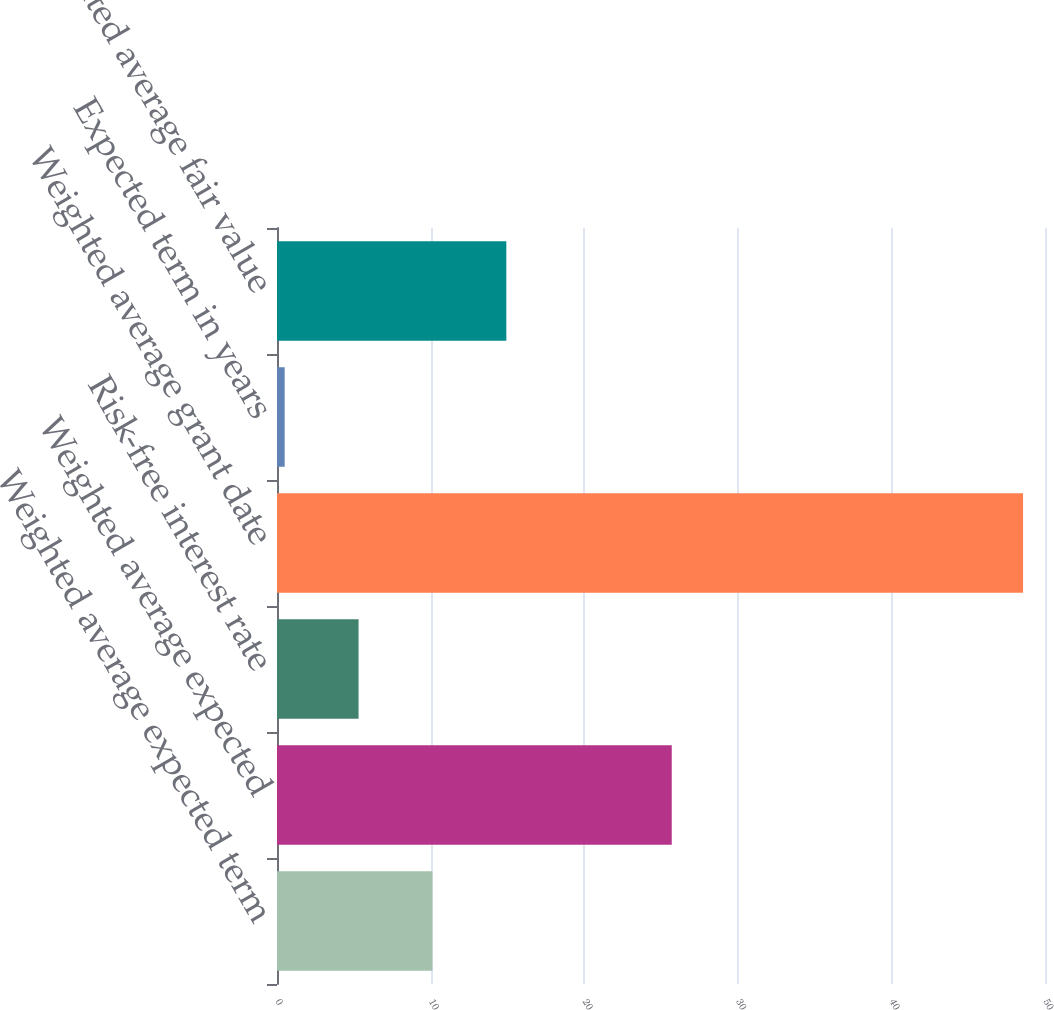Convert chart to OTSL. <chart><loc_0><loc_0><loc_500><loc_500><bar_chart><fcel>Weighted average expected term<fcel>Weighted average expected<fcel>Risk-free interest rate<fcel>Weighted average grant date<fcel>Expected term in years<fcel>Weighted average fair value<nl><fcel>10.12<fcel>25.7<fcel>5.31<fcel>48.57<fcel>0.5<fcel>14.93<nl></chart> 